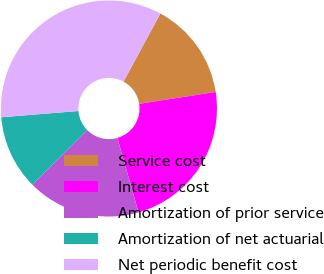Convert chart. <chart><loc_0><loc_0><loc_500><loc_500><pie_chart><fcel>Service cost<fcel>Interest cost<fcel>Amortization of prior service<fcel>Amortization of net actuarial<fcel>Net periodic benefit cost<nl><fcel>14.65%<fcel>23.03%<fcel>16.96%<fcel>11.17%<fcel>34.19%<nl></chart> 